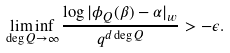Convert formula to latex. <formula><loc_0><loc_0><loc_500><loc_500>\liminf _ { \deg Q \to \infty } \frac { \log | \phi _ { Q } ( \beta ) - \alpha | _ { w } } { q ^ { d \deg Q } } > - \epsilon .</formula> 